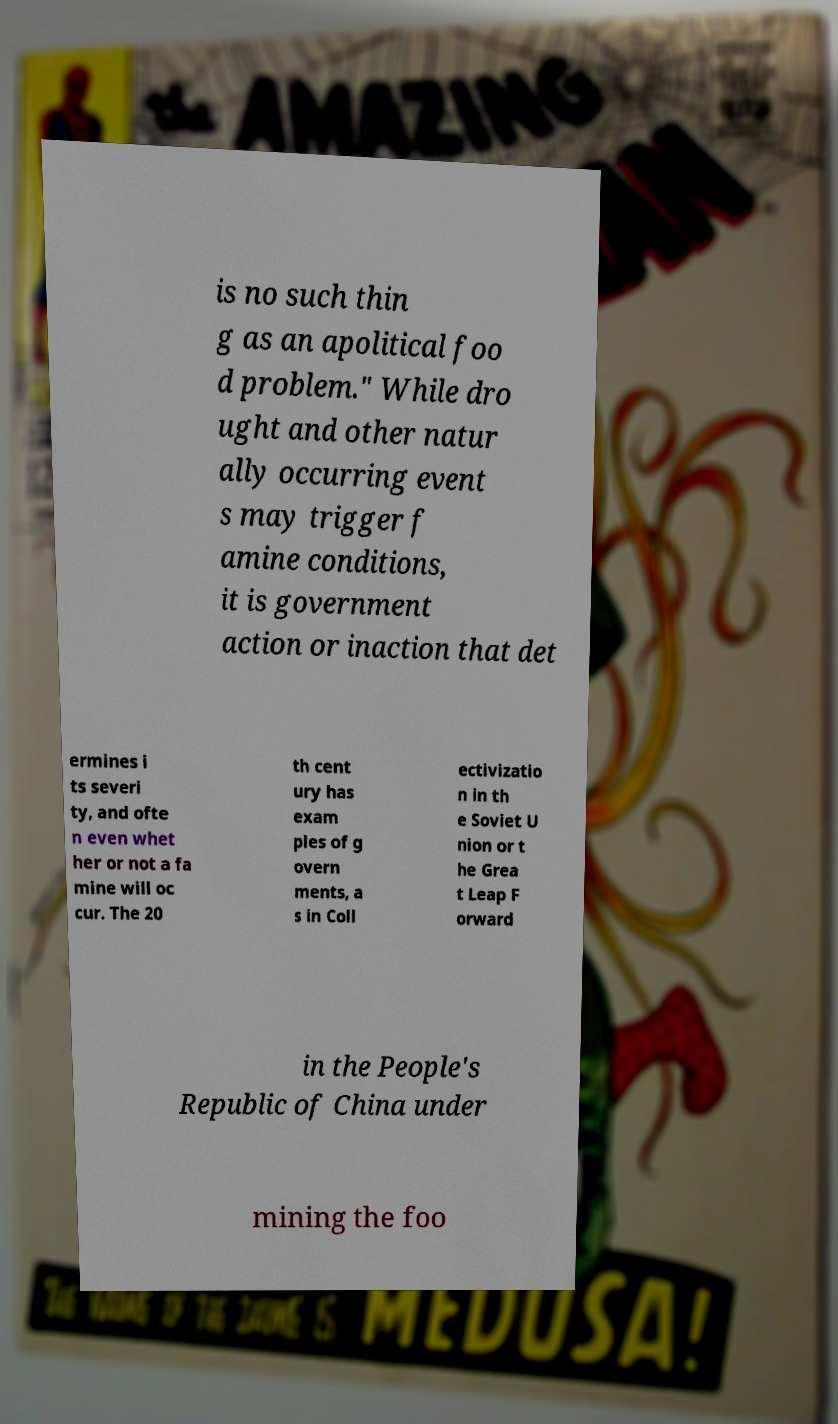What messages or text are displayed in this image? I need them in a readable, typed format. is no such thin g as an apolitical foo d problem." While dro ught and other natur ally occurring event s may trigger f amine conditions, it is government action or inaction that det ermines i ts severi ty, and ofte n even whet her or not a fa mine will oc cur. The 20 th cent ury has exam ples of g overn ments, a s in Coll ectivizatio n in th e Soviet U nion or t he Grea t Leap F orward in the People's Republic of China under mining the foo 